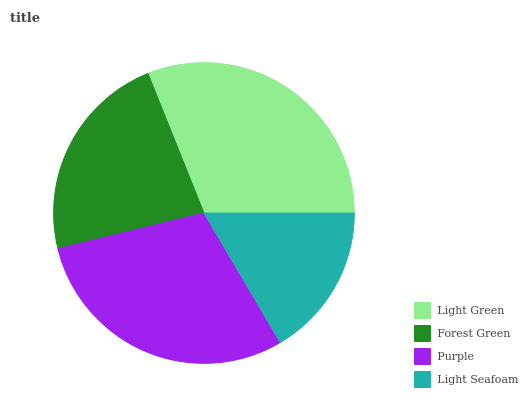Is Light Seafoam the minimum?
Answer yes or no. Yes. Is Light Green the maximum?
Answer yes or no. Yes. Is Forest Green the minimum?
Answer yes or no. No. Is Forest Green the maximum?
Answer yes or no. No. Is Light Green greater than Forest Green?
Answer yes or no. Yes. Is Forest Green less than Light Green?
Answer yes or no. Yes. Is Forest Green greater than Light Green?
Answer yes or no. No. Is Light Green less than Forest Green?
Answer yes or no. No. Is Purple the high median?
Answer yes or no. Yes. Is Forest Green the low median?
Answer yes or no. Yes. Is Light Seafoam the high median?
Answer yes or no. No. Is Purple the low median?
Answer yes or no. No. 